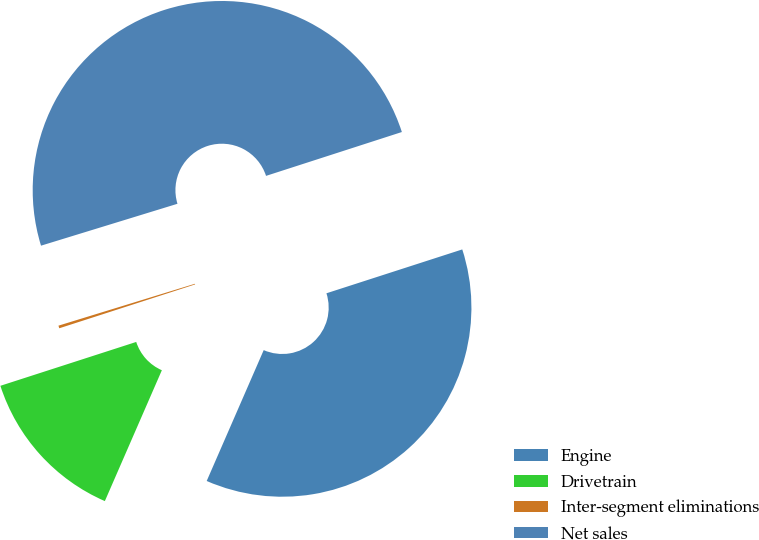Convert chart to OTSL. <chart><loc_0><loc_0><loc_500><loc_500><pie_chart><fcel>Engine<fcel>Drivetrain<fcel>Inter-segment eliminations<fcel>Net sales<nl><fcel>36.51%<fcel>13.49%<fcel>0.23%<fcel>49.77%<nl></chart> 